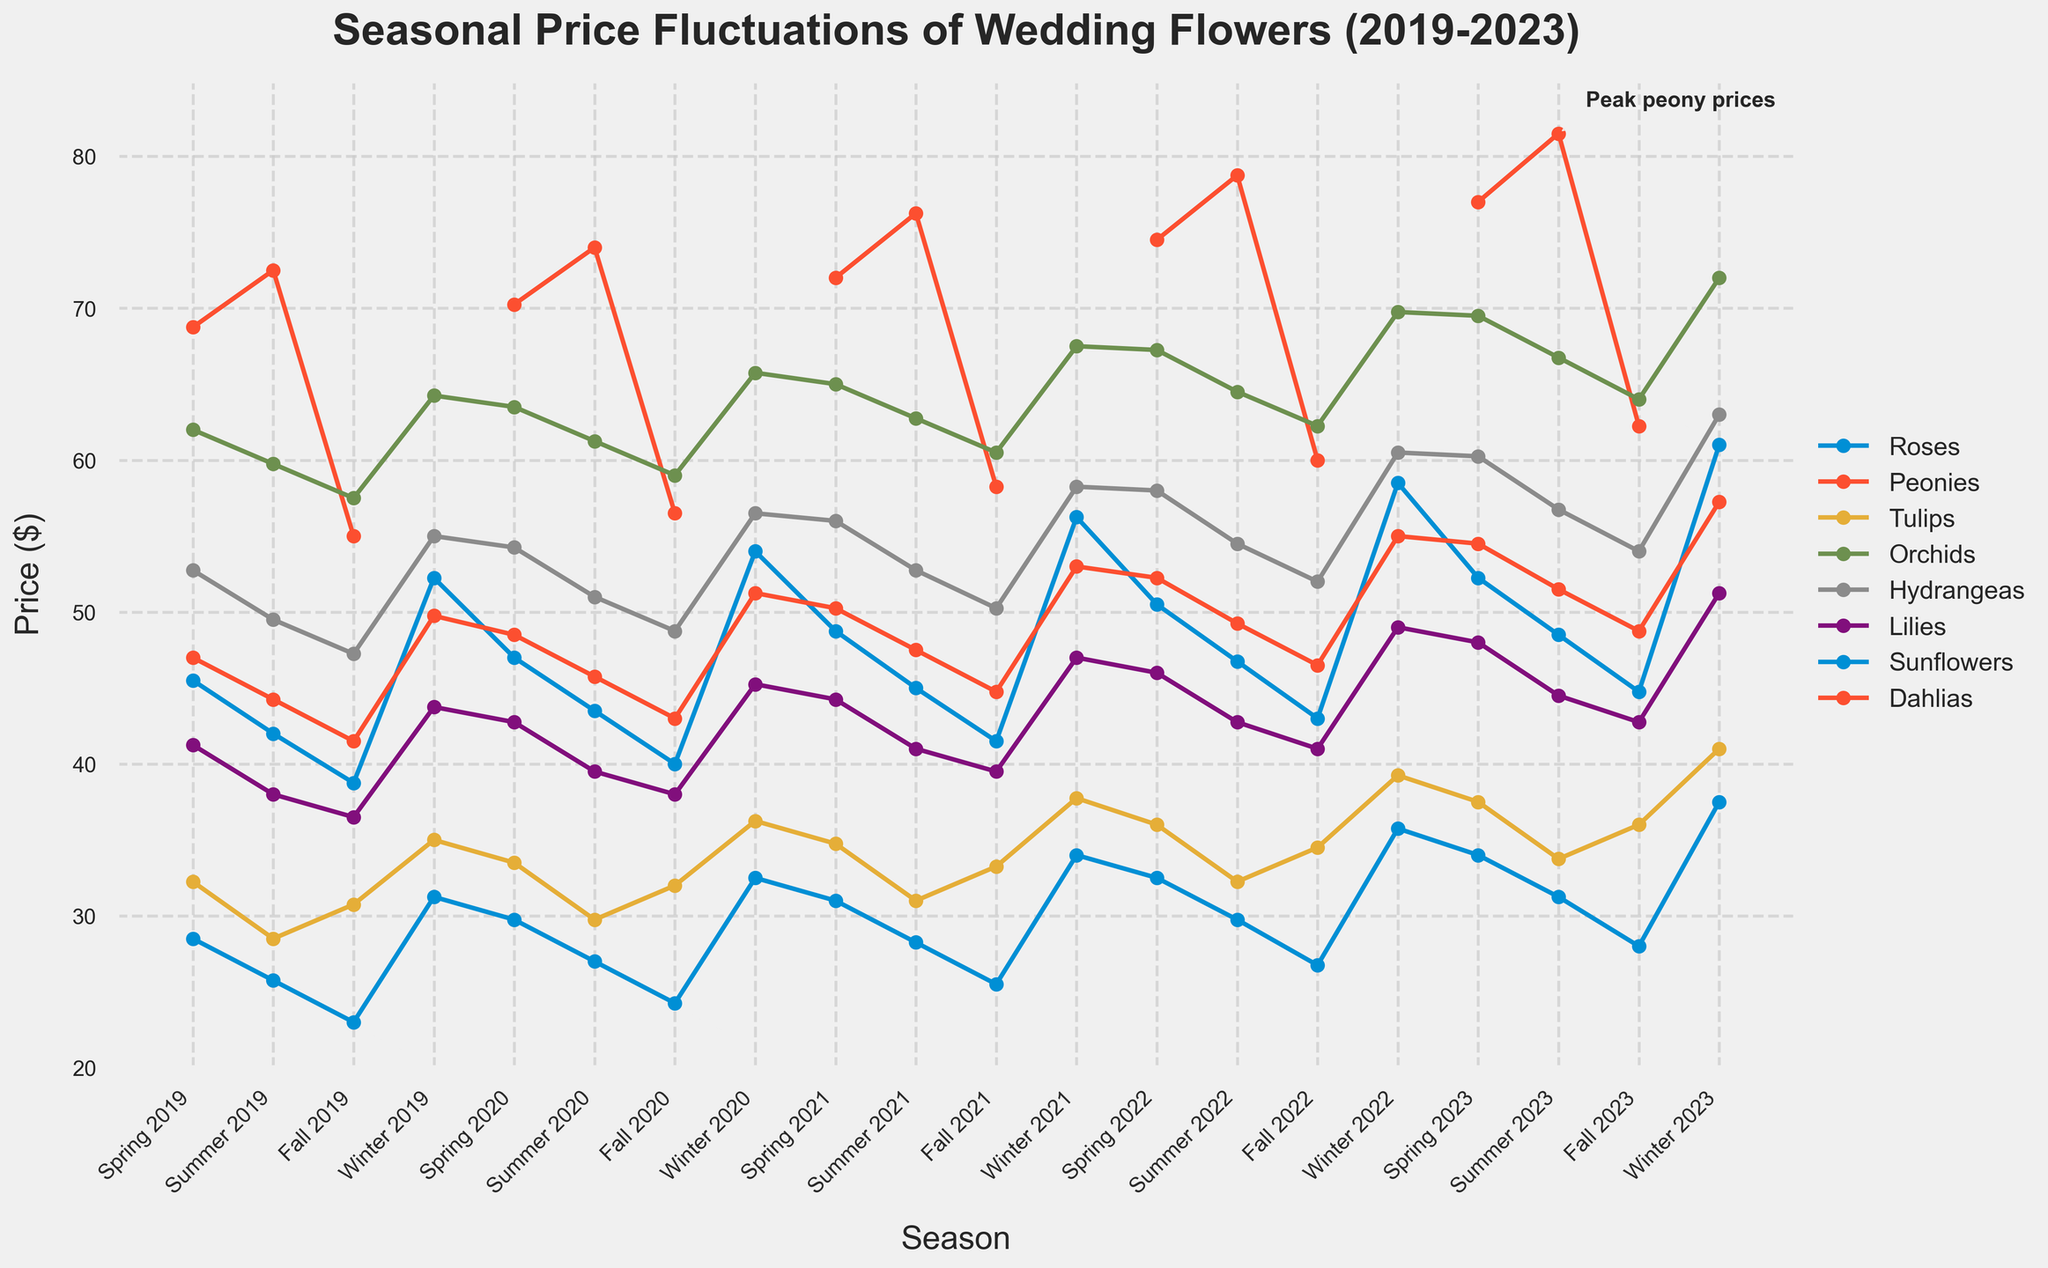What's the peak price for peonies and in which season did it occur? Identify the highest data point on the line for peonies and read the label on the x-axis to determine the season.
Answer: $81.50 in Summer 2023 How do the prices for sunflowers in Summer 2021 compare to those in Summer 2023? Locate the prices for sunflowers in Summer 2021 and Summer 2023 on the line chart and compare their values.
Answer: $28.25 in Summer 2021 and $31.25 in Summer 2023 What is the average price of orchids across all seasons in 2022? Extract the prices for orchids in Spring, Summer, Fall, and Winter of 2022, sum them up, and divide by 4 (since there are four seasons). ($67.25 + $64.50 + $62.25 + $69.75) / 4 = $65.94
Answer: $65.94 What trend do you observe in the prices of tulips from Spring 2019 to Winter 2023? Trace the tulip line from Spring 2019 to Winter 2023 and describe whether the prices generally increase, decrease, or remain stable.
Answer: Generally increasing Compare the prices of lilies in Spring 2020 and Fall 2022. What can you infer? Identify the prices of lilies in Spring 2020 and Fall 2022 on the line chart and compare their values.
Answer: $42.75 in Spring 2020 and $41.00 in Fall 2022 Which flower showed a noticeable price increase between Spring 2019 and Winter 2023? Observe the changes in line heights from Spring 2019 to Winter 2023 for each flower and identify the one with the most noticeable increase.
Answer: Roses Between Summer 2020 and Winter 2020, which flower had the most stable price? Compare the lines for all flowers between Summer 2020 and Winter 2020 and identify the one with the smallest change in prices.
Answer: Sunflowers (from $27.00 to $27.25) What was the price difference between fall and winter prices for hydrangeas in 2023? Determine the prices for hydrangeas in Fall 2023 and Winter 2023 and subtract the fall price from the winter price. $63.00 - $54.00 = $9.00
Answer: $9.00 If the trend continues, what would you predict the prices for roses to be in Spring 2024? Observe the trend in rose prices over the years and project the likely increase to the next year based on the pattern in the graph.
Answer: Around $55.00 – $70.00 (approximate extrapolation) What is the relative maximum price for orchids in the entire dataset? Identify the highest point on the line chart corresponding to orchids and note the price value.
Answer: $72.00 in Winter 2023 